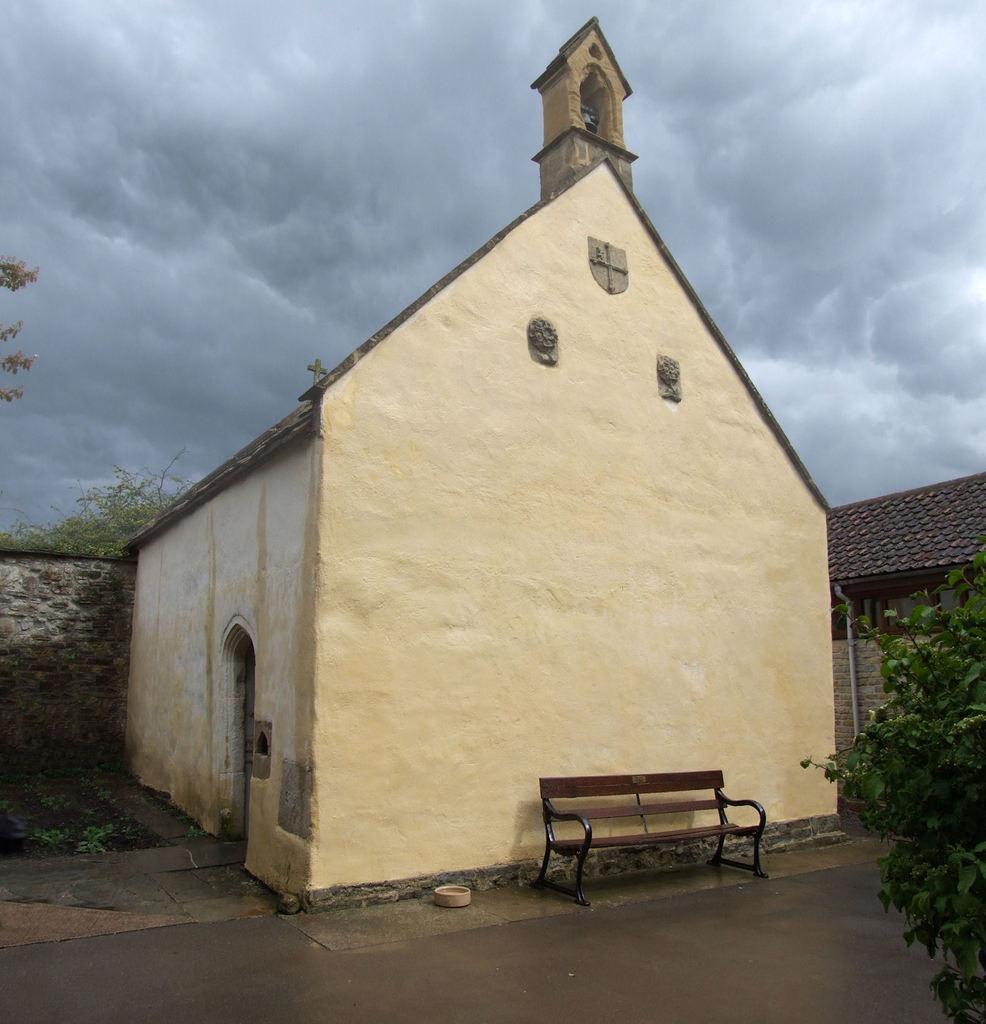Describe this image in one or two sentences. In this picture I can see houses and trees and a bench and I can see a bowl on the ground and a cloudy sky. 